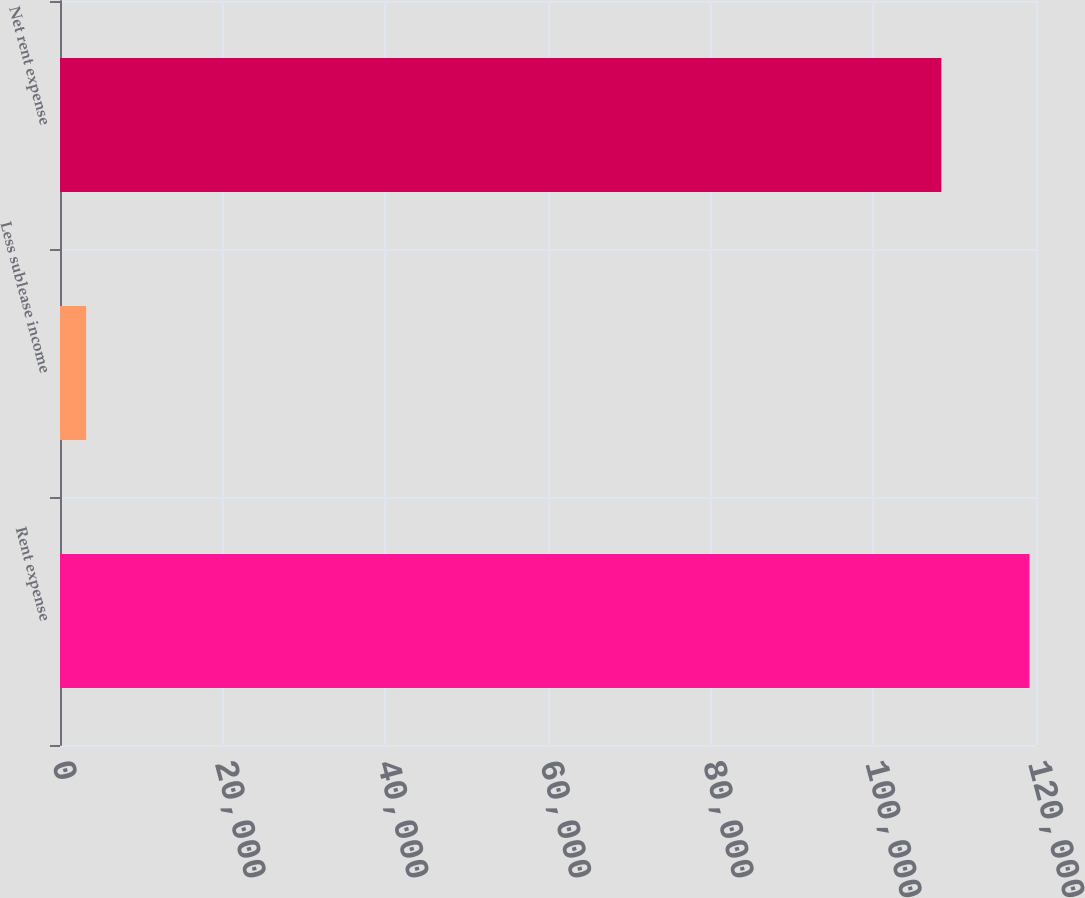Convert chart. <chart><loc_0><loc_0><loc_500><loc_500><bar_chart><fcel>Rent expense<fcel>Less sublease income<fcel>Net rent expense<nl><fcel>119199<fcel>3211<fcel>108363<nl></chart> 